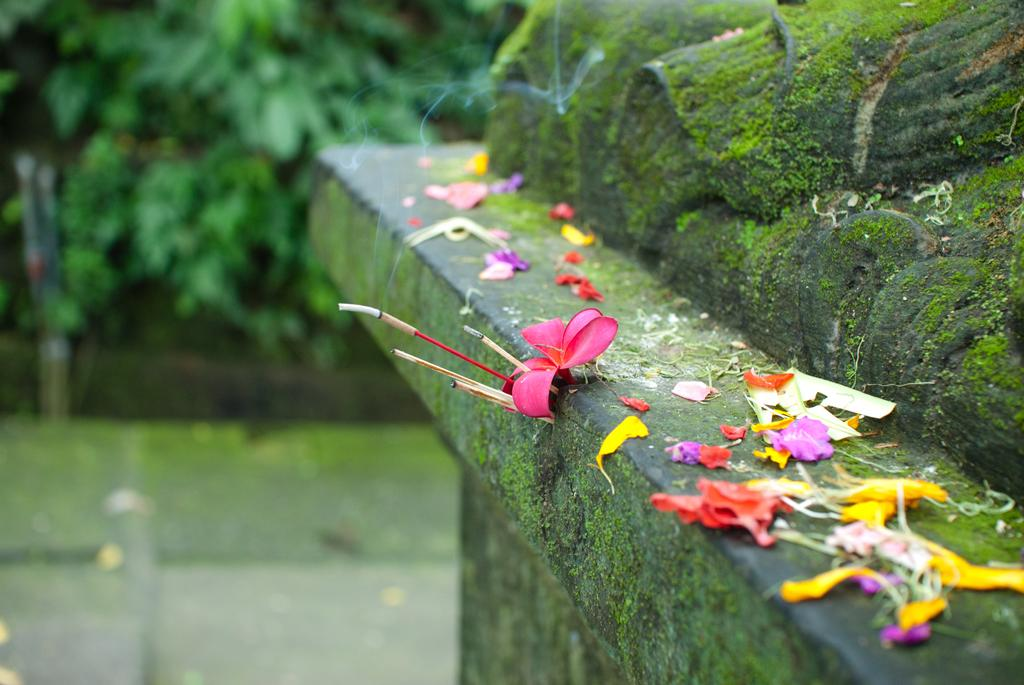What colors are the flowers in the image? The flowers in the image are pink, yellow, and purple. What can be seen in the background of the image? There are trees in the background of the image. What is the color of the trees in the image? The trees are green in color. Where are the flowers located in the image? The flowers are on a wall in the image. What type of quince is being used to hammer the flowers onto the wall in the image? There is no quince or hammer present in the image; the flowers are simply displayed on the wall. 